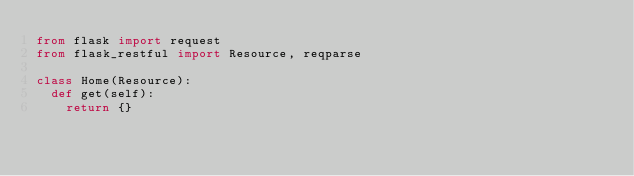<code> <loc_0><loc_0><loc_500><loc_500><_Python_>from flask import request
from flask_restful import Resource, reqparse

class Home(Resource):
  def get(self):
    return {}</code> 